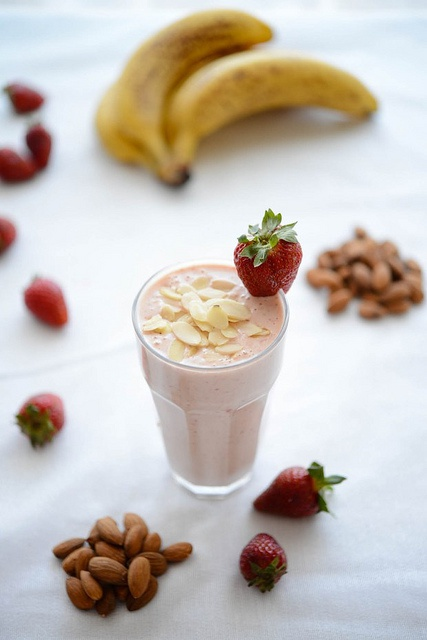Describe the objects in this image and their specific colors. I can see banana in lightgray, olive, and tan tones and cup in lightgray, darkgray, and tan tones in this image. 